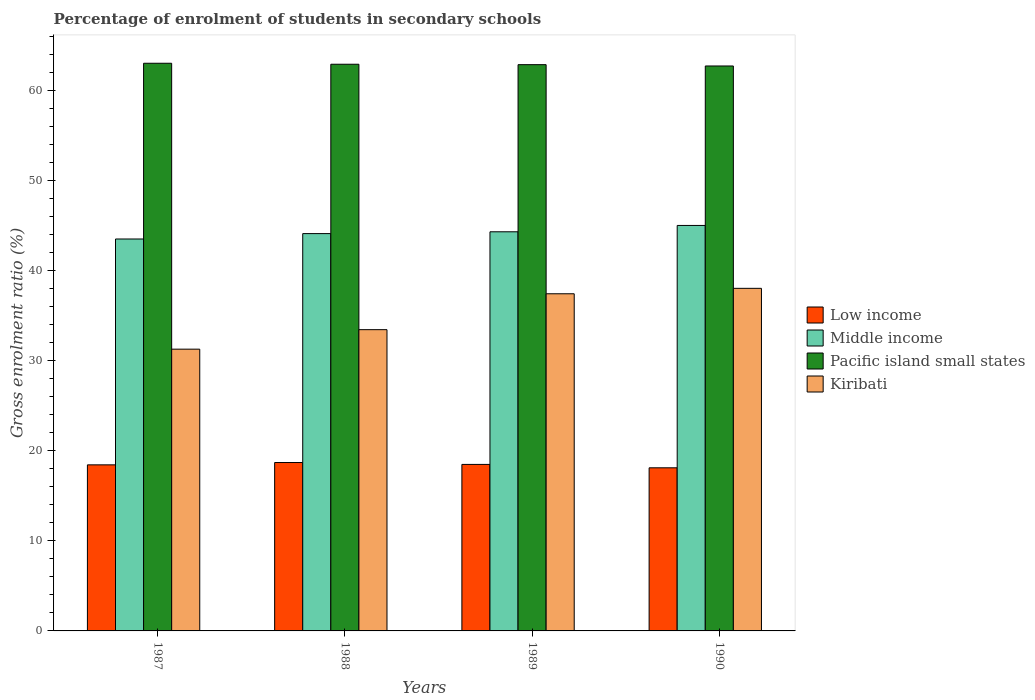How many different coloured bars are there?
Your response must be concise. 4. Are the number of bars per tick equal to the number of legend labels?
Offer a terse response. Yes. How many bars are there on the 4th tick from the left?
Offer a terse response. 4. How many bars are there on the 3rd tick from the right?
Provide a short and direct response. 4. In how many cases, is the number of bars for a given year not equal to the number of legend labels?
Your answer should be very brief. 0. What is the percentage of students enrolled in secondary schools in Low income in 1987?
Ensure brevity in your answer.  18.43. Across all years, what is the maximum percentage of students enrolled in secondary schools in Kiribati?
Provide a short and direct response. 38.02. Across all years, what is the minimum percentage of students enrolled in secondary schools in Kiribati?
Your answer should be compact. 31.27. In which year was the percentage of students enrolled in secondary schools in Kiribati maximum?
Your answer should be very brief. 1990. What is the total percentage of students enrolled in secondary schools in Pacific island small states in the graph?
Offer a very short reply. 251.42. What is the difference between the percentage of students enrolled in secondary schools in Low income in 1987 and that in 1989?
Provide a succinct answer. -0.05. What is the difference between the percentage of students enrolled in secondary schools in Kiribati in 1988 and the percentage of students enrolled in secondary schools in Low income in 1989?
Your answer should be compact. 14.95. What is the average percentage of students enrolled in secondary schools in Kiribati per year?
Keep it short and to the point. 35.03. In the year 1989, what is the difference between the percentage of students enrolled in secondary schools in Low income and percentage of students enrolled in secondary schools in Pacific island small states?
Offer a terse response. -44.36. In how many years, is the percentage of students enrolled in secondary schools in Kiribati greater than 24 %?
Provide a succinct answer. 4. What is the ratio of the percentage of students enrolled in secondary schools in Low income in 1987 to that in 1988?
Your answer should be very brief. 0.99. Is the percentage of students enrolled in secondary schools in Kiribati in 1987 less than that in 1990?
Your answer should be compact. Yes. What is the difference between the highest and the second highest percentage of students enrolled in secondary schools in Pacific island small states?
Offer a very short reply. 0.11. What is the difference between the highest and the lowest percentage of students enrolled in secondary schools in Pacific island small states?
Keep it short and to the point. 0.3. Is the sum of the percentage of students enrolled in secondary schools in Low income in 1987 and 1990 greater than the maximum percentage of students enrolled in secondary schools in Pacific island small states across all years?
Keep it short and to the point. No. What does the 4th bar from the right in 1987 represents?
Offer a very short reply. Low income. Is it the case that in every year, the sum of the percentage of students enrolled in secondary schools in Low income and percentage of students enrolled in secondary schools in Pacific island small states is greater than the percentage of students enrolled in secondary schools in Kiribati?
Your response must be concise. Yes. How many years are there in the graph?
Provide a succinct answer. 4. What is the difference between two consecutive major ticks on the Y-axis?
Your answer should be compact. 10. Are the values on the major ticks of Y-axis written in scientific E-notation?
Ensure brevity in your answer.  No. Does the graph contain any zero values?
Ensure brevity in your answer.  No. How many legend labels are there?
Make the answer very short. 4. What is the title of the graph?
Keep it short and to the point. Percentage of enrolment of students in secondary schools. What is the Gross enrolment ratio (%) of Low income in 1987?
Offer a very short reply. 18.43. What is the Gross enrolment ratio (%) of Middle income in 1987?
Your response must be concise. 43.49. What is the Gross enrolment ratio (%) of Pacific island small states in 1987?
Provide a succinct answer. 63. What is the Gross enrolment ratio (%) of Kiribati in 1987?
Offer a very short reply. 31.27. What is the Gross enrolment ratio (%) of Low income in 1988?
Make the answer very short. 18.69. What is the Gross enrolment ratio (%) in Middle income in 1988?
Provide a succinct answer. 44.09. What is the Gross enrolment ratio (%) in Pacific island small states in 1988?
Make the answer very short. 62.89. What is the Gross enrolment ratio (%) in Kiribati in 1988?
Offer a terse response. 33.43. What is the Gross enrolment ratio (%) in Low income in 1989?
Give a very brief answer. 18.48. What is the Gross enrolment ratio (%) in Middle income in 1989?
Keep it short and to the point. 44.29. What is the Gross enrolment ratio (%) in Pacific island small states in 1989?
Provide a succinct answer. 62.84. What is the Gross enrolment ratio (%) in Kiribati in 1989?
Offer a terse response. 37.41. What is the Gross enrolment ratio (%) of Low income in 1990?
Provide a short and direct response. 18.1. What is the Gross enrolment ratio (%) of Middle income in 1990?
Make the answer very short. 45. What is the Gross enrolment ratio (%) of Pacific island small states in 1990?
Offer a very short reply. 62.69. What is the Gross enrolment ratio (%) of Kiribati in 1990?
Your answer should be very brief. 38.02. Across all years, what is the maximum Gross enrolment ratio (%) of Low income?
Provide a short and direct response. 18.69. Across all years, what is the maximum Gross enrolment ratio (%) in Middle income?
Make the answer very short. 45. Across all years, what is the maximum Gross enrolment ratio (%) in Pacific island small states?
Offer a terse response. 63. Across all years, what is the maximum Gross enrolment ratio (%) of Kiribati?
Provide a short and direct response. 38.02. Across all years, what is the minimum Gross enrolment ratio (%) of Low income?
Make the answer very short. 18.1. Across all years, what is the minimum Gross enrolment ratio (%) in Middle income?
Your answer should be very brief. 43.49. Across all years, what is the minimum Gross enrolment ratio (%) in Pacific island small states?
Your response must be concise. 62.69. Across all years, what is the minimum Gross enrolment ratio (%) in Kiribati?
Offer a terse response. 31.27. What is the total Gross enrolment ratio (%) in Low income in the graph?
Offer a terse response. 73.7. What is the total Gross enrolment ratio (%) of Middle income in the graph?
Offer a terse response. 176.88. What is the total Gross enrolment ratio (%) of Pacific island small states in the graph?
Provide a succinct answer. 251.42. What is the total Gross enrolment ratio (%) of Kiribati in the graph?
Provide a short and direct response. 140.13. What is the difference between the Gross enrolment ratio (%) of Low income in 1987 and that in 1988?
Offer a very short reply. -0.26. What is the difference between the Gross enrolment ratio (%) of Middle income in 1987 and that in 1988?
Give a very brief answer. -0.6. What is the difference between the Gross enrolment ratio (%) of Pacific island small states in 1987 and that in 1988?
Give a very brief answer. 0.11. What is the difference between the Gross enrolment ratio (%) of Kiribati in 1987 and that in 1988?
Keep it short and to the point. -2.16. What is the difference between the Gross enrolment ratio (%) of Low income in 1987 and that in 1989?
Your answer should be very brief. -0.05. What is the difference between the Gross enrolment ratio (%) in Middle income in 1987 and that in 1989?
Make the answer very short. -0.8. What is the difference between the Gross enrolment ratio (%) in Pacific island small states in 1987 and that in 1989?
Offer a terse response. 0.16. What is the difference between the Gross enrolment ratio (%) in Kiribati in 1987 and that in 1989?
Ensure brevity in your answer.  -6.15. What is the difference between the Gross enrolment ratio (%) of Low income in 1987 and that in 1990?
Your answer should be very brief. 0.33. What is the difference between the Gross enrolment ratio (%) in Middle income in 1987 and that in 1990?
Provide a short and direct response. -1.5. What is the difference between the Gross enrolment ratio (%) in Pacific island small states in 1987 and that in 1990?
Your answer should be very brief. 0.3. What is the difference between the Gross enrolment ratio (%) of Kiribati in 1987 and that in 1990?
Your answer should be compact. -6.75. What is the difference between the Gross enrolment ratio (%) of Low income in 1988 and that in 1989?
Offer a very short reply. 0.21. What is the difference between the Gross enrolment ratio (%) of Middle income in 1988 and that in 1989?
Give a very brief answer. -0.2. What is the difference between the Gross enrolment ratio (%) in Pacific island small states in 1988 and that in 1989?
Keep it short and to the point. 0.05. What is the difference between the Gross enrolment ratio (%) of Kiribati in 1988 and that in 1989?
Ensure brevity in your answer.  -3.98. What is the difference between the Gross enrolment ratio (%) in Low income in 1988 and that in 1990?
Your answer should be compact. 0.59. What is the difference between the Gross enrolment ratio (%) of Middle income in 1988 and that in 1990?
Keep it short and to the point. -0.9. What is the difference between the Gross enrolment ratio (%) in Pacific island small states in 1988 and that in 1990?
Ensure brevity in your answer.  0.19. What is the difference between the Gross enrolment ratio (%) of Kiribati in 1988 and that in 1990?
Keep it short and to the point. -4.59. What is the difference between the Gross enrolment ratio (%) in Low income in 1989 and that in 1990?
Your answer should be very brief. 0.38. What is the difference between the Gross enrolment ratio (%) of Middle income in 1989 and that in 1990?
Give a very brief answer. -0.7. What is the difference between the Gross enrolment ratio (%) in Pacific island small states in 1989 and that in 1990?
Offer a terse response. 0.15. What is the difference between the Gross enrolment ratio (%) in Kiribati in 1989 and that in 1990?
Provide a short and direct response. -0.6. What is the difference between the Gross enrolment ratio (%) of Low income in 1987 and the Gross enrolment ratio (%) of Middle income in 1988?
Keep it short and to the point. -25.66. What is the difference between the Gross enrolment ratio (%) in Low income in 1987 and the Gross enrolment ratio (%) in Pacific island small states in 1988?
Offer a terse response. -44.46. What is the difference between the Gross enrolment ratio (%) in Low income in 1987 and the Gross enrolment ratio (%) in Kiribati in 1988?
Offer a terse response. -15. What is the difference between the Gross enrolment ratio (%) in Middle income in 1987 and the Gross enrolment ratio (%) in Pacific island small states in 1988?
Give a very brief answer. -19.39. What is the difference between the Gross enrolment ratio (%) of Middle income in 1987 and the Gross enrolment ratio (%) of Kiribati in 1988?
Ensure brevity in your answer.  10.06. What is the difference between the Gross enrolment ratio (%) in Pacific island small states in 1987 and the Gross enrolment ratio (%) in Kiribati in 1988?
Offer a very short reply. 29.56. What is the difference between the Gross enrolment ratio (%) of Low income in 1987 and the Gross enrolment ratio (%) of Middle income in 1989?
Offer a very short reply. -25.86. What is the difference between the Gross enrolment ratio (%) in Low income in 1987 and the Gross enrolment ratio (%) in Pacific island small states in 1989?
Ensure brevity in your answer.  -44.41. What is the difference between the Gross enrolment ratio (%) of Low income in 1987 and the Gross enrolment ratio (%) of Kiribati in 1989?
Offer a very short reply. -18.98. What is the difference between the Gross enrolment ratio (%) in Middle income in 1987 and the Gross enrolment ratio (%) in Pacific island small states in 1989?
Provide a succinct answer. -19.35. What is the difference between the Gross enrolment ratio (%) in Middle income in 1987 and the Gross enrolment ratio (%) in Kiribati in 1989?
Offer a very short reply. 6.08. What is the difference between the Gross enrolment ratio (%) of Pacific island small states in 1987 and the Gross enrolment ratio (%) of Kiribati in 1989?
Your response must be concise. 25.58. What is the difference between the Gross enrolment ratio (%) of Low income in 1987 and the Gross enrolment ratio (%) of Middle income in 1990?
Your answer should be very brief. -26.57. What is the difference between the Gross enrolment ratio (%) in Low income in 1987 and the Gross enrolment ratio (%) in Pacific island small states in 1990?
Keep it short and to the point. -44.26. What is the difference between the Gross enrolment ratio (%) of Low income in 1987 and the Gross enrolment ratio (%) of Kiribati in 1990?
Your response must be concise. -19.59. What is the difference between the Gross enrolment ratio (%) in Middle income in 1987 and the Gross enrolment ratio (%) in Pacific island small states in 1990?
Your answer should be very brief. -19.2. What is the difference between the Gross enrolment ratio (%) in Middle income in 1987 and the Gross enrolment ratio (%) in Kiribati in 1990?
Offer a terse response. 5.48. What is the difference between the Gross enrolment ratio (%) in Pacific island small states in 1987 and the Gross enrolment ratio (%) in Kiribati in 1990?
Offer a very short reply. 24.98. What is the difference between the Gross enrolment ratio (%) in Low income in 1988 and the Gross enrolment ratio (%) in Middle income in 1989?
Ensure brevity in your answer.  -25.61. What is the difference between the Gross enrolment ratio (%) in Low income in 1988 and the Gross enrolment ratio (%) in Pacific island small states in 1989?
Give a very brief answer. -44.15. What is the difference between the Gross enrolment ratio (%) of Low income in 1988 and the Gross enrolment ratio (%) of Kiribati in 1989?
Make the answer very short. -18.73. What is the difference between the Gross enrolment ratio (%) of Middle income in 1988 and the Gross enrolment ratio (%) of Pacific island small states in 1989?
Your answer should be compact. -18.75. What is the difference between the Gross enrolment ratio (%) of Middle income in 1988 and the Gross enrolment ratio (%) of Kiribati in 1989?
Make the answer very short. 6.68. What is the difference between the Gross enrolment ratio (%) of Pacific island small states in 1988 and the Gross enrolment ratio (%) of Kiribati in 1989?
Keep it short and to the point. 25.47. What is the difference between the Gross enrolment ratio (%) in Low income in 1988 and the Gross enrolment ratio (%) in Middle income in 1990?
Keep it short and to the point. -26.31. What is the difference between the Gross enrolment ratio (%) in Low income in 1988 and the Gross enrolment ratio (%) in Pacific island small states in 1990?
Your answer should be compact. -44.01. What is the difference between the Gross enrolment ratio (%) of Low income in 1988 and the Gross enrolment ratio (%) of Kiribati in 1990?
Give a very brief answer. -19.33. What is the difference between the Gross enrolment ratio (%) in Middle income in 1988 and the Gross enrolment ratio (%) in Pacific island small states in 1990?
Offer a terse response. -18.6. What is the difference between the Gross enrolment ratio (%) in Middle income in 1988 and the Gross enrolment ratio (%) in Kiribati in 1990?
Give a very brief answer. 6.08. What is the difference between the Gross enrolment ratio (%) of Pacific island small states in 1988 and the Gross enrolment ratio (%) of Kiribati in 1990?
Ensure brevity in your answer.  24.87. What is the difference between the Gross enrolment ratio (%) in Low income in 1989 and the Gross enrolment ratio (%) in Middle income in 1990?
Ensure brevity in your answer.  -26.52. What is the difference between the Gross enrolment ratio (%) of Low income in 1989 and the Gross enrolment ratio (%) of Pacific island small states in 1990?
Provide a succinct answer. -44.22. What is the difference between the Gross enrolment ratio (%) in Low income in 1989 and the Gross enrolment ratio (%) in Kiribati in 1990?
Provide a succinct answer. -19.54. What is the difference between the Gross enrolment ratio (%) in Middle income in 1989 and the Gross enrolment ratio (%) in Pacific island small states in 1990?
Make the answer very short. -18.4. What is the difference between the Gross enrolment ratio (%) in Middle income in 1989 and the Gross enrolment ratio (%) in Kiribati in 1990?
Ensure brevity in your answer.  6.28. What is the difference between the Gross enrolment ratio (%) in Pacific island small states in 1989 and the Gross enrolment ratio (%) in Kiribati in 1990?
Your answer should be very brief. 24.82. What is the average Gross enrolment ratio (%) of Low income per year?
Provide a succinct answer. 18.42. What is the average Gross enrolment ratio (%) in Middle income per year?
Give a very brief answer. 44.22. What is the average Gross enrolment ratio (%) of Pacific island small states per year?
Your answer should be very brief. 62.85. What is the average Gross enrolment ratio (%) of Kiribati per year?
Give a very brief answer. 35.03. In the year 1987, what is the difference between the Gross enrolment ratio (%) in Low income and Gross enrolment ratio (%) in Middle income?
Keep it short and to the point. -25.06. In the year 1987, what is the difference between the Gross enrolment ratio (%) in Low income and Gross enrolment ratio (%) in Pacific island small states?
Provide a short and direct response. -44.57. In the year 1987, what is the difference between the Gross enrolment ratio (%) in Low income and Gross enrolment ratio (%) in Kiribati?
Ensure brevity in your answer.  -12.84. In the year 1987, what is the difference between the Gross enrolment ratio (%) in Middle income and Gross enrolment ratio (%) in Pacific island small states?
Your answer should be very brief. -19.5. In the year 1987, what is the difference between the Gross enrolment ratio (%) in Middle income and Gross enrolment ratio (%) in Kiribati?
Offer a very short reply. 12.23. In the year 1987, what is the difference between the Gross enrolment ratio (%) of Pacific island small states and Gross enrolment ratio (%) of Kiribati?
Give a very brief answer. 31.73. In the year 1988, what is the difference between the Gross enrolment ratio (%) of Low income and Gross enrolment ratio (%) of Middle income?
Your answer should be very brief. -25.41. In the year 1988, what is the difference between the Gross enrolment ratio (%) of Low income and Gross enrolment ratio (%) of Pacific island small states?
Provide a succinct answer. -44.2. In the year 1988, what is the difference between the Gross enrolment ratio (%) of Low income and Gross enrolment ratio (%) of Kiribati?
Your answer should be compact. -14.74. In the year 1988, what is the difference between the Gross enrolment ratio (%) in Middle income and Gross enrolment ratio (%) in Pacific island small states?
Give a very brief answer. -18.79. In the year 1988, what is the difference between the Gross enrolment ratio (%) in Middle income and Gross enrolment ratio (%) in Kiribati?
Keep it short and to the point. 10.66. In the year 1988, what is the difference between the Gross enrolment ratio (%) of Pacific island small states and Gross enrolment ratio (%) of Kiribati?
Your response must be concise. 29.45. In the year 1989, what is the difference between the Gross enrolment ratio (%) in Low income and Gross enrolment ratio (%) in Middle income?
Offer a terse response. -25.81. In the year 1989, what is the difference between the Gross enrolment ratio (%) in Low income and Gross enrolment ratio (%) in Pacific island small states?
Make the answer very short. -44.36. In the year 1989, what is the difference between the Gross enrolment ratio (%) in Low income and Gross enrolment ratio (%) in Kiribati?
Your response must be concise. -18.94. In the year 1989, what is the difference between the Gross enrolment ratio (%) in Middle income and Gross enrolment ratio (%) in Pacific island small states?
Make the answer very short. -18.55. In the year 1989, what is the difference between the Gross enrolment ratio (%) in Middle income and Gross enrolment ratio (%) in Kiribati?
Offer a very short reply. 6.88. In the year 1989, what is the difference between the Gross enrolment ratio (%) in Pacific island small states and Gross enrolment ratio (%) in Kiribati?
Ensure brevity in your answer.  25.43. In the year 1990, what is the difference between the Gross enrolment ratio (%) of Low income and Gross enrolment ratio (%) of Middle income?
Offer a terse response. -26.9. In the year 1990, what is the difference between the Gross enrolment ratio (%) in Low income and Gross enrolment ratio (%) in Pacific island small states?
Your response must be concise. -44.59. In the year 1990, what is the difference between the Gross enrolment ratio (%) of Low income and Gross enrolment ratio (%) of Kiribati?
Your answer should be compact. -19.92. In the year 1990, what is the difference between the Gross enrolment ratio (%) of Middle income and Gross enrolment ratio (%) of Pacific island small states?
Ensure brevity in your answer.  -17.7. In the year 1990, what is the difference between the Gross enrolment ratio (%) of Middle income and Gross enrolment ratio (%) of Kiribati?
Ensure brevity in your answer.  6.98. In the year 1990, what is the difference between the Gross enrolment ratio (%) of Pacific island small states and Gross enrolment ratio (%) of Kiribati?
Your answer should be very brief. 24.68. What is the ratio of the Gross enrolment ratio (%) of Low income in 1987 to that in 1988?
Your response must be concise. 0.99. What is the ratio of the Gross enrolment ratio (%) in Middle income in 1987 to that in 1988?
Give a very brief answer. 0.99. What is the ratio of the Gross enrolment ratio (%) of Pacific island small states in 1987 to that in 1988?
Provide a succinct answer. 1. What is the ratio of the Gross enrolment ratio (%) of Kiribati in 1987 to that in 1988?
Provide a short and direct response. 0.94. What is the ratio of the Gross enrolment ratio (%) in Kiribati in 1987 to that in 1989?
Provide a succinct answer. 0.84. What is the ratio of the Gross enrolment ratio (%) in Low income in 1987 to that in 1990?
Your response must be concise. 1.02. What is the ratio of the Gross enrolment ratio (%) of Middle income in 1987 to that in 1990?
Offer a very short reply. 0.97. What is the ratio of the Gross enrolment ratio (%) of Pacific island small states in 1987 to that in 1990?
Your answer should be compact. 1. What is the ratio of the Gross enrolment ratio (%) in Kiribati in 1987 to that in 1990?
Give a very brief answer. 0.82. What is the ratio of the Gross enrolment ratio (%) in Low income in 1988 to that in 1989?
Ensure brevity in your answer.  1.01. What is the ratio of the Gross enrolment ratio (%) in Middle income in 1988 to that in 1989?
Provide a succinct answer. 1. What is the ratio of the Gross enrolment ratio (%) in Kiribati in 1988 to that in 1989?
Offer a very short reply. 0.89. What is the ratio of the Gross enrolment ratio (%) of Low income in 1988 to that in 1990?
Your answer should be compact. 1.03. What is the ratio of the Gross enrolment ratio (%) in Middle income in 1988 to that in 1990?
Provide a succinct answer. 0.98. What is the ratio of the Gross enrolment ratio (%) in Pacific island small states in 1988 to that in 1990?
Provide a succinct answer. 1. What is the ratio of the Gross enrolment ratio (%) of Kiribati in 1988 to that in 1990?
Provide a succinct answer. 0.88. What is the ratio of the Gross enrolment ratio (%) of Low income in 1989 to that in 1990?
Ensure brevity in your answer.  1.02. What is the ratio of the Gross enrolment ratio (%) in Middle income in 1989 to that in 1990?
Your answer should be compact. 0.98. What is the ratio of the Gross enrolment ratio (%) of Kiribati in 1989 to that in 1990?
Your answer should be very brief. 0.98. What is the difference between the highest and the second highest Gross enrolment ratio (%) in Low income?
Your answer should be very brief. 0.21. What is the difference between the highest and the second highest Gross enrolment ratio (%) in Middle income?
Ensure brevity in your answer.  0.7. What is the difference between the highest and the second highest Gross enrolment ratio (%) of Pacific island small states?
Keep it short and to the point. 0.11. What is the difference between the highest and the second highest Gross enrolment ratio (%) of Kiribati?
Keep it short and to the point. 0.6. What is the difference between the highest and the lowest Gross enrolment ratio (%) of Low income?
Provide a short and direct response. 0.59. What is the difference between the highest and the lowest Gross enrolment ratio (%) of Middle income?
Make the answer very short. 1.5. What is the difference between the highest and the lowest Gross enrolment ratio (%) of Pacific island small states?
Make the answer very short. 0.3. What is the difference between the highest and the lowest Gross enrolment ratio (%) of Kiribati?
Offer a terse response. 6.75. 